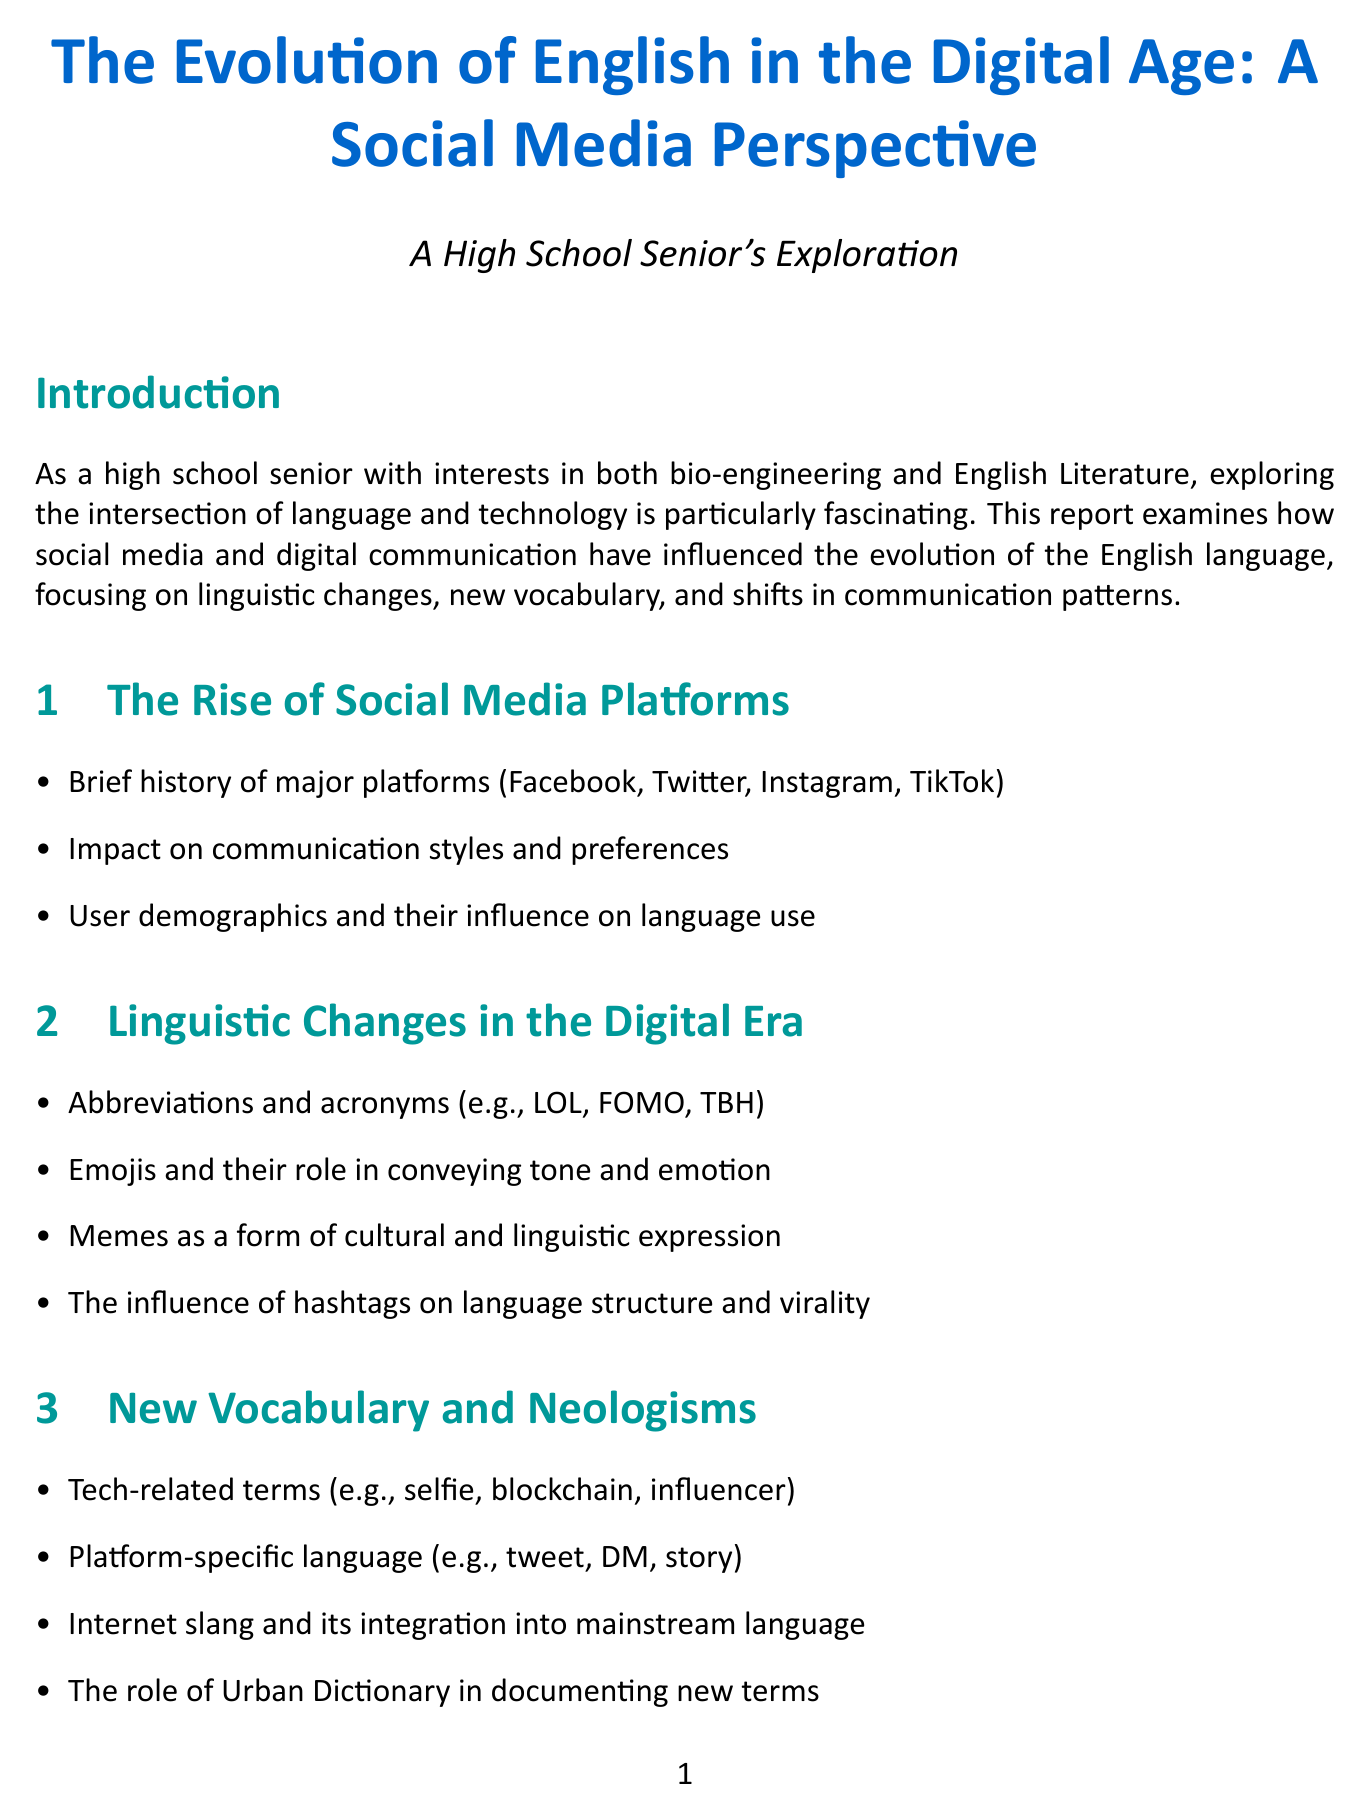What is the title of the report? The title is explicitly mentioned at the beginning of the document.
Answer: The Evolution of English in the Digital Age: A Social Media Perspective How many major social media platforms are discussed in the report? The report lists four major platforms in the content section discussing the rise of social media platforms.
Answer: Four What is one example of internet slang mentioned in the report? The report provides examples of linguistic changes in the digital era, including abbreviations and acronyms.
Answer: LOL Which organizations are cited in the data and statistics section? The sources of the statistics are explicitly enumerated in the document.
Answer: Pew Research Center, Oxford English Dictionary What is the character limit for Twitter posts mentioned in the case study? The case study focused on Twitter explicitly mentions this limit.
Answer: 280 What type of new terms does Urban Dictionary document according to the report? The report mentions a specific role that Urban Dictionary plays in language evolution.
Answer: New terms What type of impact does digital communication have on contemporary literature? The implications section indicates a specific influence of digital communication on literature.
Answer: Influence How many new words were added by the Oxford English Dictionary in 2020? The relevant findings in the data and statistics section provide this number.
Answer: Over 1,000 